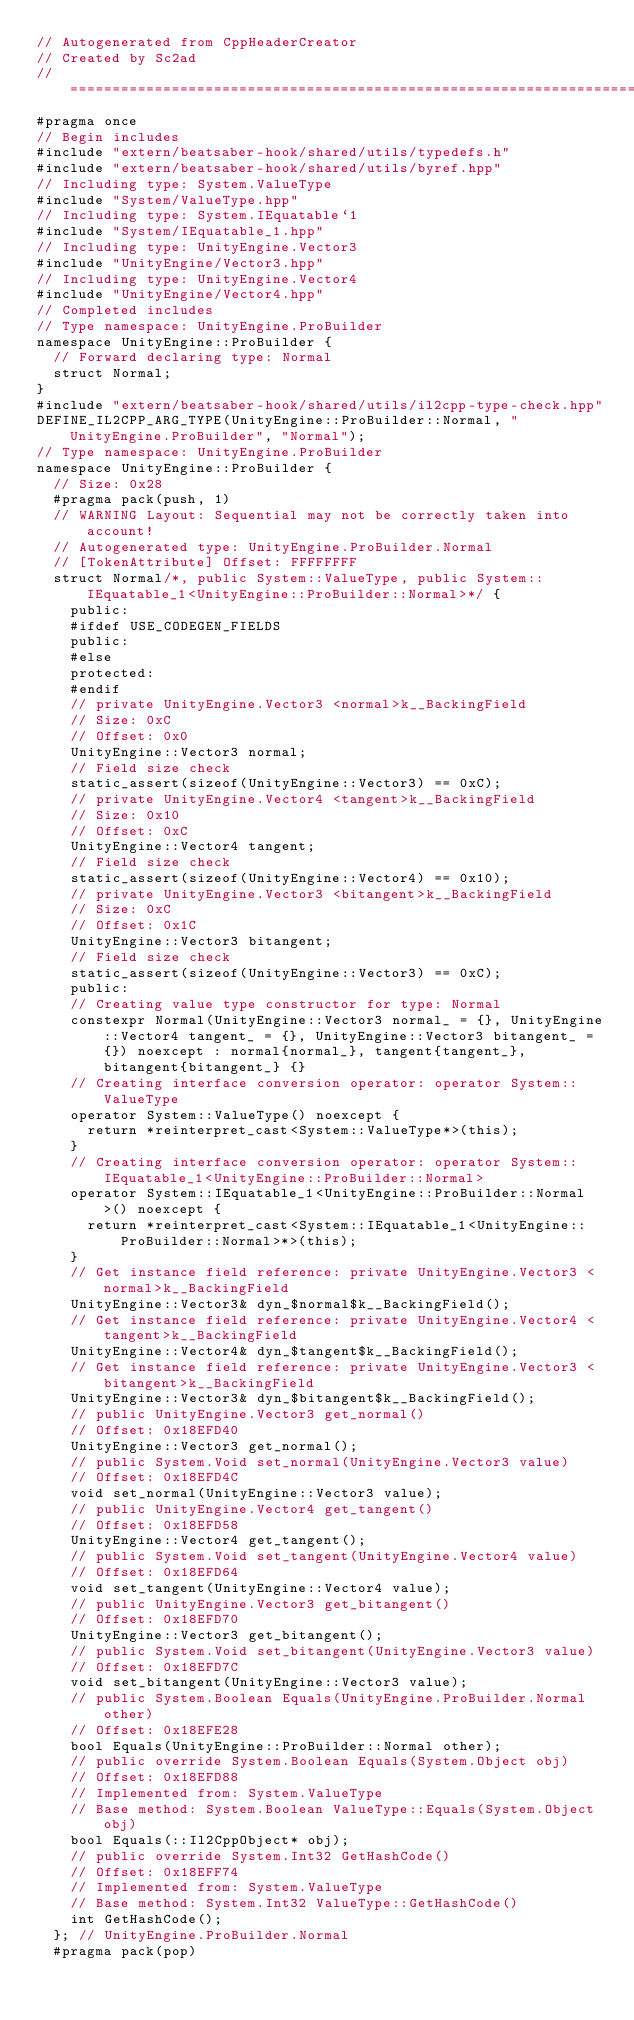Convert code to text. <code><loc_0><loc_0><loc_500><loc_500><_C++_>// Autogenerated from CppHeaderCreator
// Created by Sc2ad
// =========================================================================
#pragma once
// Begin includes
#include "extern/beatsaber-hook/shared/utils/typedefs.h"
#include "extern/beatsaber-hook/shared/utils/byref.hpp"
// Including type: System.ValueType
#include "System/ValueType.hpp"
// Including type: System.IEquatable`1
#include "System/IEquatable_1.hpp"
// Including type: UnityEngine.Vector3
#include "UnityEngine/Vector3.hpp"
// Including type: UnityEngine.Vector4
#include "UnityEngine/Vector4.hpp"
// Completed includes
// Type namespace: UnityEngine.ProBuilder
namespace UnityEngine::ProBuilder {
  // Forward declaring type: Normal
  struct Normal;
}
#include "extern/beatsaber-hook/shared/utils/il2cpp-type-check.hpp"
DEFINE_IL2CPP_ARG_TYPE(UnityEngine::ProBuilder::Normal, "UnityEngine.ProBuilder", "Normal");
// Type namespace: UnityEngine.ProBuilder
namespace UnityEngine::ProBuilder {
  // Size: 0x28
  #pragma pack(push, 1)
  // WARNING Layout: Sequential may not be correctly taken into account!
  // Autogenerated type: UnityEngine.ProBuilder.Normal
  // [TokenAttribute] Offset: FFFFFFFF
  struct Normal/*, public System::ValueType, public System::IEquatable_1<UnityEngine::ProBuilder::Normal>*/ {
    public:
    #ifdef USE_CODEGEN_FIELDS
    public:
    #else
    protected:
    #endif
    // private UnityEngine.Vector3 <normal>k__BackingField
    // Size: 0xC
    // Offset: 0x0
    UnityEngine::Vector3 normal;
    // Field size check
    static_assert(sizeof(UnityEngine::Vector3) == 0xC);
    // private UnityEngine.Vector4 <tangent>k__BackingField
    // Size: 0x10
    // Offset: 0xC
    UnityEngine::Vector4 tangent;
    // Field size check
    static_assert(sizeof(UnityEngine::Vector4) == 0x10);
    // private UnityEngine.Vector3 <bitangent>k__BackingField
    // Size: 0xC
    // Offset: 0x1C
    UnityEngine::Vector3 bitangent;
    // Field size check
    static_assert(sizeof(UnityEngine::Vector3) == 0xC);
    public:
    // Creating value type constructor for type: Normal
    constexpr Normal(UnityEngine::Vector3 normal_ = {}, UnityEngine::Vector4 tangent_ = {}, UnityEngine::Vector3 bitangent_ = {}) noexcept : normal{normal_}, tangent{tangent_}, bitangent{bitangent_} {}
    // Creating interface conversion operator: operator System::ValueType
    operator System::ValueType() noexcept {
      return *reinterpret_cast<System::ValueType*>(this);
    }
    // Creating interface conversion operator: operator System::IEquatable_1<UnityEngine::ProBuilder::Normal>
    operator System::IEquatable_1<UnityEngine::ProBuilder::Normal>() noexcept {
      return *reinterpret_cast<System::IEquatable_1<UnityEngine::ProBuilder::Normal>*>(this);
    }
    // Get instance field reference: private UnityEngine.Vector3 <normal>k__BackingField
    UnityEngine::Vector3& dyn_$normal$k__BackingField();
    // Get instance field reference: private UnityEngine.Vector4 <tangent>k__BackingField
    UnityEngine::Vector4& dyn_$tangent$k__BackingField();
    // Get instance field reference: private UnityEngine.Vector3 <bitangent>k__BackingField
    UnityEngine::Vector3& dyn_$bitangent$k__BackingField();
    // public UnityEngine.Vector3 get_normal()
    // Offset: 0x18EFD40
    UnityEngine::Vector3 get_normal();
    // public System.Void set_normal(UnityEngine.Vector3 value)
    // Offset: 0x18EFD4C
    void set_normal(UnityEngine::Vector3 value);
    // public UnityEngine.Vector4 get_tangent()
    // Offset: 0x18EFD58
    UnityEngine::Vector4 get_tangent();
    // public System.Void set_tangent(UnityEngine.Vector4 value)
    // Offset: 0x18EFD64
    void set_tangent(UnityEngine::Vector4 value);
    // public UnityEngine.Vector3 get_bitangent()
    // Offset: 0x18EFD70
    UnityEngine::Vector3 get_bitangent();
    // public System.Void set_bitangent(UnityEngine.Vector3 value)
    // Offset: 0x18EFD7C
    void set_bitangent(UnityEngine::Vector3 value);
    // public System.Boolean Equals(UnityEngine.ProBuilder.Normal other)
    // Offset: 0x18EFE28
    bool Equals(UnityEngine::ProBuilder::Normal other);
    // public override System.Boolean Equals(System.Object obj)
    // Offset: 0x18EFD88
    // Implemented from: System.ValueType
    // Base method: System.Boolean ValueType::Equals(System.Object obj)
    bool Equals(::Il2CppObject* obj);
    // public override System.Int32 GetHashCode()
    // Offset: 0x18EFF74
    // Implemented from: System.ValueType
    // Base method: System.Int32 ValueType::GetHashCode()
    int GetHashCode();
  }; // UnityEngine.ProBuilder.Normal
  #pragma pack(pop)</code> 